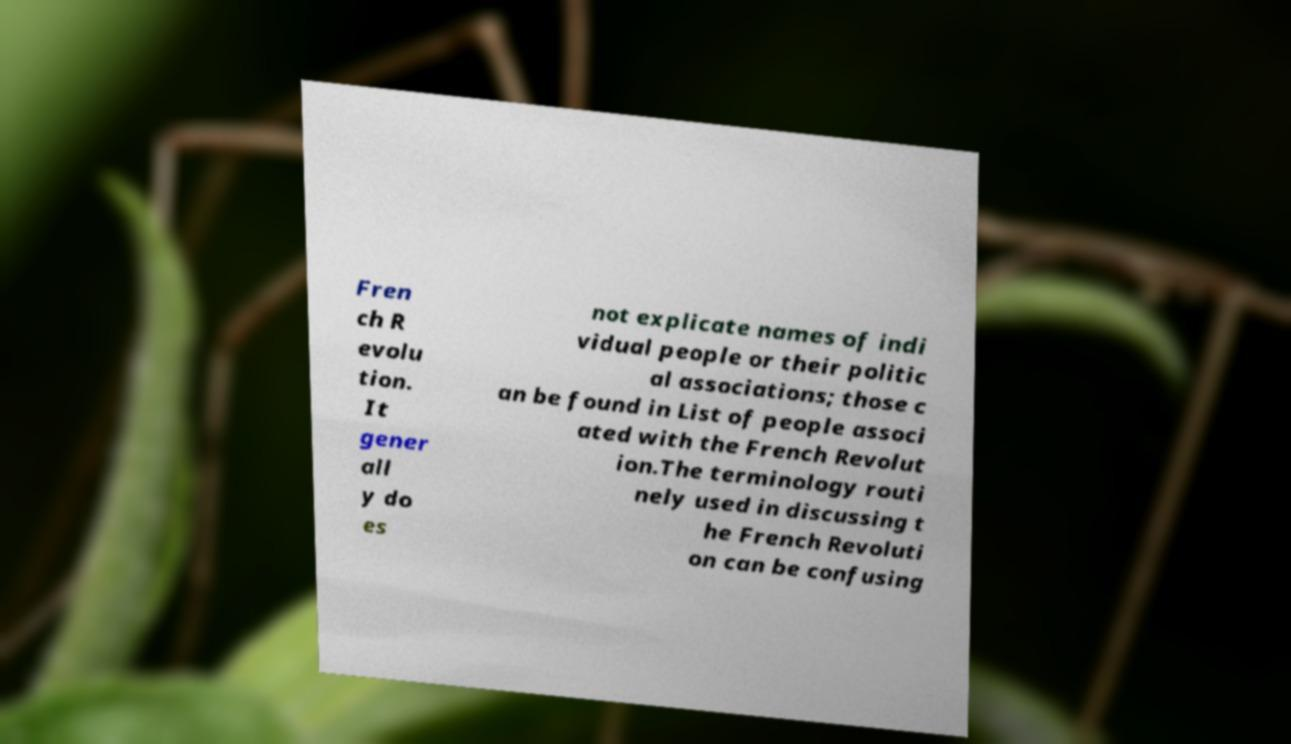Can you read and provide the text displayed in the image?This photo seems to have some interesting text. Can you extract and type it out for me? Fren ch R evolu tion. It gener all y do es not explicate names of indi vidual people or their politic al associations; those c an be found in List of people associ ated with the French Revolut ion.The terminology routi nely used in discussing t he French Revoluti on can be confusing 